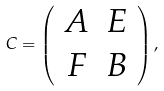<formula> <loc_0><loc_0><loc_500><loc_500>C = \left ( \begin{array} { c c } A & E \\ F & B \end{array} \right ) ,</formula> 